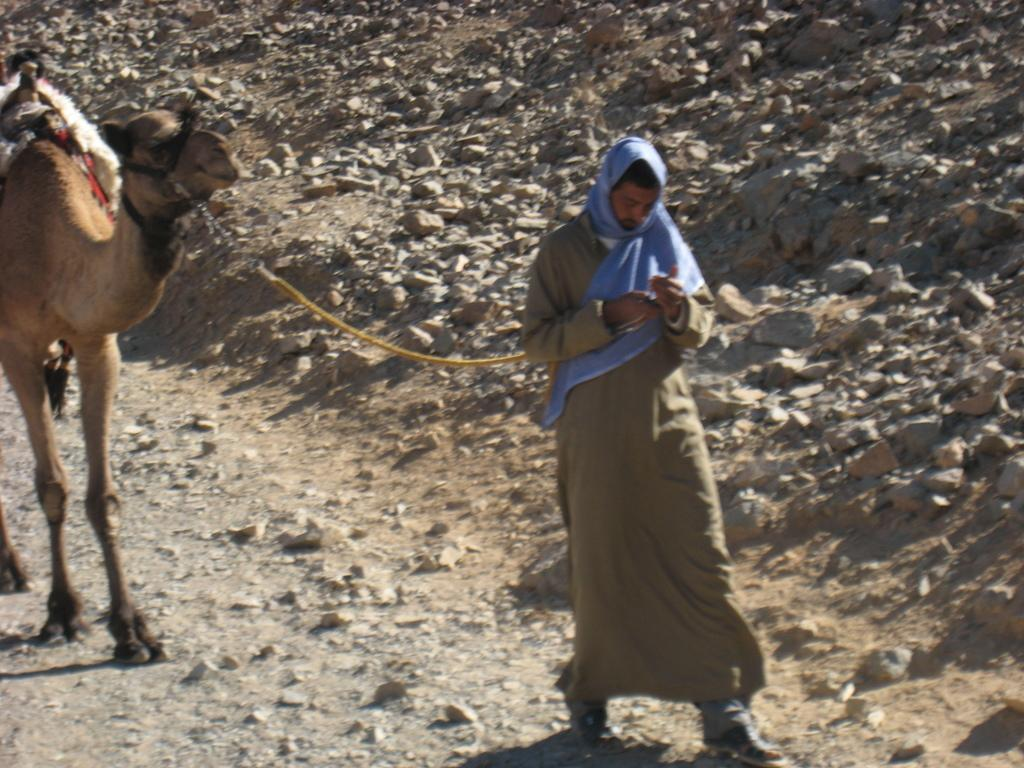What is the main subject of the image? There is a man in the image. What is the man doing in the image? The man is walking in the image. What is the man holding in the image? The man is holding a rope in the image. What is the rope connected to? The rope is tied to a camel in the image. Where is the camel located in the image? The camel is on a path in the image. What type of terrain can be seen in the image? There are rocks and stones visible in the image. What type of collar is the camel wearing in the image? There is no collar visible on the camel in the image. What type of smoke can be seen coming from the rocks in the image? There is no smoke present in the image; it only features a man walking with a rope tied to a camel on a path with rocks and stones. 